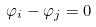<formula> <loc_0><loc_0><loc_500><loc_500>\varphi _ { i } - \varphi _ { j } = 0</formula> 